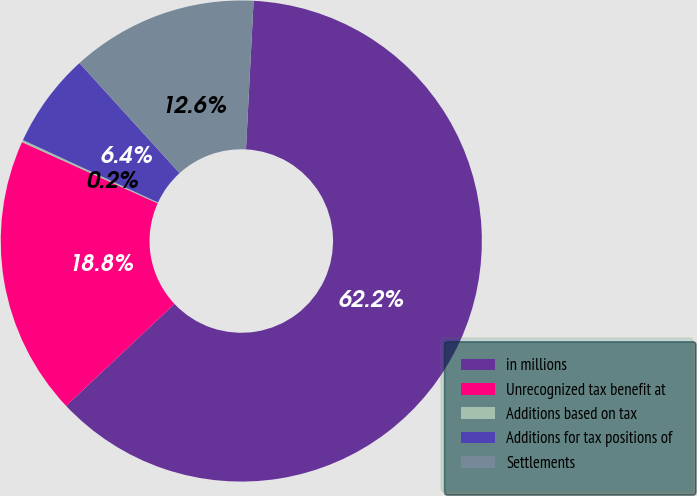Convert chart. <chart><loc_0><loc_0><loc_500><loc_500><pie_chart><fcel>in millions<fcel>Unrecognized tax benefit at<fcel>Additions based on tax<fcel>Additions for tax positions of<fcel>Settlements<nl><fcel>62.17%<fcel>18.76%<fcel>0.15%<fcel>6.36%<fcel>12.56%<nl></chart> 